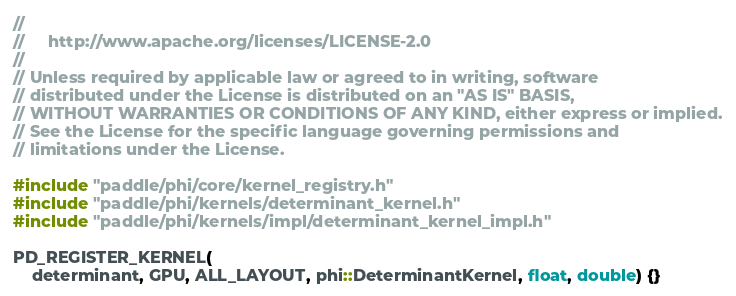<code> <loc_0><loc_0><loc_500><loc_500><_Cuda_>//
//     http://www.apache.org/licenses/LICENSE-2.0
//
// Unless required by applicable law or agreed to in writing, software
// distributed under the License is distributed on an "AS IS" BASIS,
// WITHOUT WARRANTIES OR CONDITIONS OF ANY KIND, either express or implied.
// See the License for the specific language governing permissions and
// limitations under the License.

#include "paddle/phi/core/kernel_registry.h"
#include "paddle/phi/kernels/determinant_kernel.h"
#include "paddle/phi/kernels/impl/determinant_kernel_impl.h"

PD_REGISTER_KERNEL(
    determinant, GPU, ALL_LAYOUT, phi::DeterminantKernel, float, double) {}
</code> 